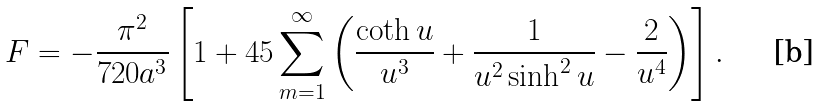<formula> <loc_0><loc_0><loc_500><loc_500>F = - \frac { \pi ^ { 2 } } { 7 2 0 a ^ { 3 } } \left [ 1 + 4 5 \sum _ { m = 1 } ^ { \infty } \left ( \frac { \coth u } { u ^ { 3 } } + \frac { 1 } { u ^ { 2 } \sinh ^ { 2 } u } - \frac { 2 } { u ^ { 4 } } \right ) \right ] .</formula> 